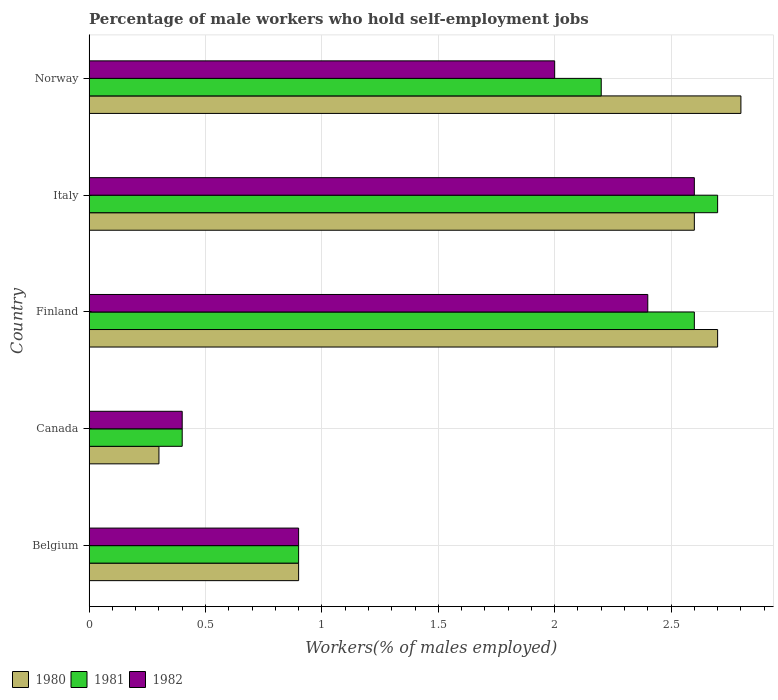How many different coloured bars are there?
Make the answer very short. 3. How many groups of bars are there?
Provide a short and direct response. 5. Are the number of bars on each tick of the Y-axis equal?
Offer a very short reply. Yes. How many bars are there on the 1st tick from the top?
Ensure brevity in your answer.  3. How many bars are there on the 4th tick from the bottom?
Your answer should be compact. 3. What is the percentage of self-employed male workers in 1981 in Finland?
Offer a very short reply. 2.6. Across all countries, what is the maximum percentage of self-employed male workers in 1980?
Provide a short and direct response. 2.8. Across all countries, what is the minimum percentage of self-employed male workers in 1980?
Your answer should be very brief. 0.3. In which country was the percentage of self-employed male workers in 1981 minimum?
Keep it short and to the point. Canada. What is the total percentage of self-employed male workers in 1980 in the graph?
Your answer should be compact. 9.3. What is the difference between the percentage of self-employed male workers in 1982 in Finland and that in Norway?
Ensure brevity in your answer.  0.4. What is the difference between the percentage of self-employed male workers in 1980 in Italy and the percentage of self-employed male workers in 1982 in Canada?
Your response must be concise. 2.2. What is the average percentage of self-employed male workers in 1982 per country?
Make the answer very short. 1.66. What is the difference between the percentage of self-employed male workers in 1982 and percentage of self-employed male workers in 1980 in Finland?
Offer a terse response. -0.3. In how many countries, is the percentage of self-employed male workers in 1980 greater than 1.2 %?
Make the answer very short. 3. What is the ratio of the percentage of self-employed male workers in 1981 in Canada to that in Norway?
Your response must be concise. 0.18. What is the difference between the highest and the second highest percentage of self-employed male workers in 1981?
Your response must be concise. 0.1. What is the difference between the highest and the lowest percentage of self-employed male workers in 1982?
Make the answer very short. 2.2. In how many countries, is the percentage of self-employed male workers in 1980 greater than the average percentage of self-employed male workers in 1980 taken over all countries?
Provide a succinct answer. 3. Is the sum of the percentage of self-employed male workers in 1981 in Canada and Norway greater than the maximum percentage of self-employed male workers in 1980 across all countries?
Provide a succinct answer. No. What does the 2nd bar from the bottom in Canada represents?
Provide a short and direct response. 1981. How many bars are there?
Make the answer very short. 15. Are all the bars in the graph horizontal?
Give a very brief answer. Yes. What is the difference between two consecutive major ticks on the X-axis?
Offer a terse response. 0.5. Are the values on the major ticks of X-axis written in scientific E-notation?
Provide a succinct answer. No. Does the graph contain any zero values?
Provide a short and direct response. No. Where does the legend appear in the graph?
Provide a succinct answer. Bottom left. How many legend labels are there?
Ensure brevity in your answer.  3. What is the title of the graph?
Your response must be concise. Percentage of male workers who hold self-employment jobs. What is the label or title of the X-axis?
Keep it short and to the point. Workers(% of males employed). What is the Workers(% of males employed) of 1980 in Belgium?
Provide a short and direct response. 0.9. What is the Workers(% of males employed) in 1981 in Belgium?
Your answer should be very brief. 0.9. What is the Workers(% of males employed) in 1982 in Belgium?
Keep it short and to the point. 0.9. What is the Workers(% of males employed) of 1980 in Canada?
Offer a terse response. 0.3. What is the Workers(% of males employed) in 1981 in Canada?
Offer a terse response. 0.4. What is the Workers(% of males employed) of 1982 in Canada?
Provide a short and direct response. 0.4. What is the Workers(% of males employed) in 1980 in Finland?
Provide a short and direct response. 2.7. What is the Workers(% of males employed) in 1981 in Finland?
Make the answer very short. 2.6. What is the Workers(% of males employed) in 1982 in Finland?
Give a very brief answer. 2.4. What is the Workers(% of males employed) of 1980 in Italy?
Your answer should be very brief. 2.6. What is the Workers(% of males employed) of 1981 in Italy?
Ensure brevity in your answer.  2.7. What is the Workers(% of males employed) of 1982 in Italy?
Ensure brevity in your answer.  2.6. What is the Workers(% of males employed) of 1980 in Norway?
Your answer should be compact. 2.8. What is the Workers(% of males employed) of 1981 in Norway?
Provide a short and direct response. 2.2. Across all countries, what is the maximum Workers(% of males employed) of 1980?
Provide a succinct answer. 2.8. Across all countries, what is the maximum Workers(% of males employed) of 1981?
Keep it short and to the point. 2.7. Across all countries, what is the maximum Workers(% of males employed) in 1982?
Your answer should be very brief. 2.6. Across all countries, what is the minimum Workers(% of males employed) in 1980?
Offer a terse response. 0.3. Across all countries, what is the minimum Workers(% of males employed) in 1981?
Provide a short and direct response. 0.4. Across all countries, what is the minimum Workers(% of males employed) of 1982?
Your answer should be very brief. 0.4. What is the total Workers(% of males employed) of 1980 in the graph?
Provide a short and direct response. 9.3. What is the total Workers(% of males employed) in 1981 in the graph?
Your answer should be compact. 8.8. What is the difference between the Workers(% of males employed) of 1980 in Belgium and that in Canada?
Your answer should be compact. 0.6. What is the difference between the Workers(% of males employed) of 1980 in Belgium and that in Finland?
Offer a terse response. -1.8. What is the difference between the Workers(% of males employed) of 1982 in Belgium and that in Finland?
Your answer should be very brief. -1.5. What is the difference between the Workers(% of males employed) in 1980 in Belgium and that in Italy?
Keep it short and to the point. -1.7. What is the difference between the Workers(% of males employed) in 1981 in Belgium and that in Italy?
Offer a very short reply. -1.8. What is the difference between the Workers(% of males employed) in 1982 in Belgium and that in Norway?
Give a very brief answer. -1.1. What is the difference between the Workers(% of males employed) in 1981 in Canada and that in Finland?
Your answer should be compact. -2.2. What is the difference between the Workers(% of males employed) in 1982 in Canada and that in Finland?
Make the answer very short. -2. What is the difference between the Workers(% of males employed) in 1980 in Canada and that in Italy?
Keep it short and to the point. -2.3. What is the difference between the Workers(% of males employed) in 1981 in Canada and that in Italy?
Your answer should be very brief. -2.3. What is the difference between the Workers(% of males employed) in 1981 in Canada and that in Norway?
Your response must be concise. -1.8. What is the difference between the Workers(% of males employed) of 1980 in Finland and that in Italy?
Make the answer very short. 0.1. What is the difference between the Workers(% of males employed) of 1981 in Finland and that in Italy?
Give a very brief answer. -0.1. What is the difference between the Workers(% of males employed) of 1981 in Finland and that in Norway?
Provide a succinct answer. 0.4. What is the difference between the Workers(% of males employed) of 1982 in Finland and that in Norway?
Make the answer very short. 0.4. What is the difference between the Workers(% of males employed) of 1980 in Belgium and the Workers(% of males employed) of 1981 in Canada?
Provide a succinct answer. 0.5. What is the difference between the Workers(% of males employed) of 1980 in Belgium and the Workers(% of males employed) of 1982 in Canada?
Keep it short and to the point. 0.5. What is the difference between the Workers(% of males employed) in 1980 in Belgium and the Workers(% of males employed) in 1982 in Finland?
Your response must be concise. -1.5. What is the difference between the Workers(% of males employed) in 1981 in Belgium and the Workers(% of males employed) in 1982 in Italy?
Make the answer very short. -1.7. What is the difference between the Workers(% of males employed) in 1981 in Belgium and the Workers(% of males employed) in 1982 in Norway?
Make the answer very short. -1.1. What is the difference between the Workers(% of males employed) of 1980 in Canada and the Workers(% of males employed) of 1982 in Finland?
Provide a succinct answer. -2.1. What is the difference between the Workers(% of males employed) of 1980 in Canada and the Workers(% of males employed) of 1982 in Italy?
Your response must be concise. -2.3. What is the difference between the Workers(% of males employed) of 1981 in Canada and the Workers(% of males employed) of 1982 in Italy?
Make the answer very short. -2.2. What is the difference between the Workers(% of males employed) of 1980 in Canada and the Workers(% of males employed) of 1981 in Norway?
Offer a very short reply. -1.9. What is the difference between the Workers(% of males employed) in 1981 in Canada and the Workers(% of males employed) in 1982 in Norway?
Your answer should be very brief. -1.6. What is the difference between the Workers(% of males employed) of 1981 in Finland and the Workers(% of males employed) of 1982 in Italy?
Keep it short and to the point. 0. What is the difference between the Workers(% of males employed) in 1980 in Finland and the Workers(% of males employed) in 1981 in Norway?
Make the answer very short. 0.5. What is the difference between the Workers(% of males employed) in 1981 in Finland and the Workers(% of males employed) in 1982 in Norway?
Your answer should be compact. 0.6. What is the difference between the Workers(% of males employed) of 1980 in Italy and the Workers(% of males employed) of 1982 in Norway?
Offer a terse response. 0.6. What is the difference between the Workers(% of males employed) in 1981 in Italy and the Workers(% of males employed) in 1982 in Norway?
Your response must be concise. 0.7. What is the average Workers(% of males employed) in 1980 per country?
Offer a very short reply. 1.86. What is the average Workers(% of males employed) of 1981 per country?
Provide a short and direct response. 1.76. What is the average Workers(% of males employed) in 1982 per country?
Make the answer very short. 1.66. What is the difference between the Workers(% of males employed) in 1980 and Workers(% of males employed) in 1982 in Belgium?
Offer a very short reply. 0. What is the difference between the Workers(% of males employed) in 1981 and Workers(% of males employed) in 1982 in Canada?
Provide a short and direct response. 0. What is the difference between the Workers(% of males employed) in 1981 and Workers(% of males employed) in 1982 in Finland?
Ensure brevity in your answer.  0.2. What is the difference between the Workers(% of males employed) of 1980 and Workers(% of males employed) of 1981 in Italy?
Your answer should be very brief. -0.1. What is the difference between the Workers(% of males employed) of 1980 and Workers(% of males employed) of 1982 in Italy?
Your response must be concise. 0. What is the difference between the Workers(% of males employed) in 1980 and Workers(% of males employed) in 1981 in Norway?
Your answer should be very brief. 0.6. What is the ratio of the Workers(% of males employed) of 1981 in Belgium to that in Canada?
Make the answer very short. 2.25. What is the ratio of the Workers(% of males employed) in 1982 in Belgium to that in Canada?
Offer a very short reply. 2.25. What is the ratio of the Workers(% of males employed) in 1980 in Belgium to that in Finland?
Keep it short and to the point. 0.33. What is the ratio of the Workers(% of males employed) in 1981 in Belgium to that in Finland?
Provide a short and direct response. 0.35. What is the ratio of the Workers(% of males employed) of 1982 in Belgium to that in Finland?
Provide a succinct answer. 0.38. What is the ratio of the Workers(% of males employed) in 1980 in Belgium to that in Italy?
Offer a terse response. 0.35. What is the ratio of the Workers(% of males employed) in 1981 in Belgium to that in Italy?
Provide a short and direct response. 0.33. What is the ratio of the Workers(% of males employed) of 1982 in Belgium to that in Italy?
Provide a succinct answer. 0.35. What is the ratio of the Workers(% of males employed) of 1980 in Belgium to that in Norway?
Keep it short and to the point. 0.32. What is the ratio of the Workers(% of males employed) in 1981 in Belgium to that in Norway?
Your answer should be compact. 0.41. What is the ratio of the Workers(% of males employed) in 1982 in Belgium to that in Norway?
Your answer should be very brief. 0.45. What is the ratio of the Workers(% of males employed) in 1980 in Canada to that in Finland?
Offer a terse response. 0.11. What is the ratio of the Workers(% of males employed) in 1981 in Canada to that in Finland?
Give a very brief answer. 0.15. What is the ratio of the Workers(% of males employed) in 1980 in Canada to that in Italy?
Offer a very short reply. 0.12. What is the ratio of the Workers(% of males employed) of 1981 in Canada to that in Italy?
Ensure brevity in your answer.  0.15. What is the ratio of the Workers(% of males employed) in 1982 in Canada to that in Italy?
Make the answer very short. 0.15. What is the ratio of the Workers(% of males employed) of 1980 in Canada to that in Norway?
Offer a terse response. 0.11. What is the ratio of the Workers(% of males employed) in 1981 in Canada to that in Norway?
Offer a terse response. 0.18. What is the ratio of the Workers(% of males employed) of 1980 in Finland to that in Italy?
Offer a terse response. 1.04. What is the ratio of the Workers(% of males employed) of 1982 in Finland to that in Italy?
Your response must be concise. 0.92. What is the ratio of the Workers(% of males employed) of 1980 in Finland to that in Norway?
Your answer should be compact. 0.96. What is the ratio of the Workers(% of males employed) of 1981 in Finland to that in Norway?
Your answer should be compact. 1.18. What is the ratio of the Workers(% of males employed) in 1981 in Italy to that in Norway?
Offer a very short reply. 1.23. What is the difference between the highest and the second highest Workers(% of males employed) of 1982?
Offer a very short reply. 0.2. What is the difference between the highest and the lowest Workers(% of males employed) of 1980?
Your answer should be compact. 2.5. What is the difference between the highest and the lowest Workers(% of males employed) of 1982?
Offer a very short reply. 2.2. 